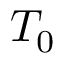<formula> <loc_0><loc_0><loc_500><loc_500>T _ { 0 }</formula> 